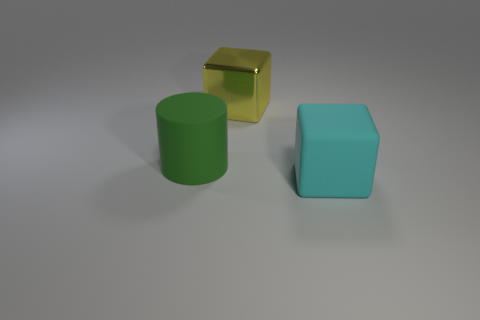How many other things are there of the same size as the metal cube?
Offer a terse response. 2. What size is the cube that is in front of the cube that is left of the cyan matte block?
Your answer should be very brief. Large. What color is the rubber object that is left of the rubber object that is in front of the matte thing that is on the left side of the big cyan rubber thing?
Offer a terse response. Green. What is the size of the thing that is right of the big green cylinder and left of the cyan cube?
Your answer should be compact. Large. How many other things are there of the same shape as the metallic object?
Offer a very short reply. 1. What number of cylinders are yellow shiny objects or large rubber objects?
Keep it short and to the point. 1. There is a thing that is on the right side of the big object that is behind the cylinder; is there a rubber cylinder on the left side of it?
Your response must be concise. Yes. What is the color of the other thing that is the same shape as the cyan thing?
Offer a terse response. Yellow. How many yellow things are shiny blocks or tiny balls?
Give a very brief answer. 1. What material is the block that is to the left of the big object in front of the large green rubber cylinder?
Make the answer very short. Metal. 